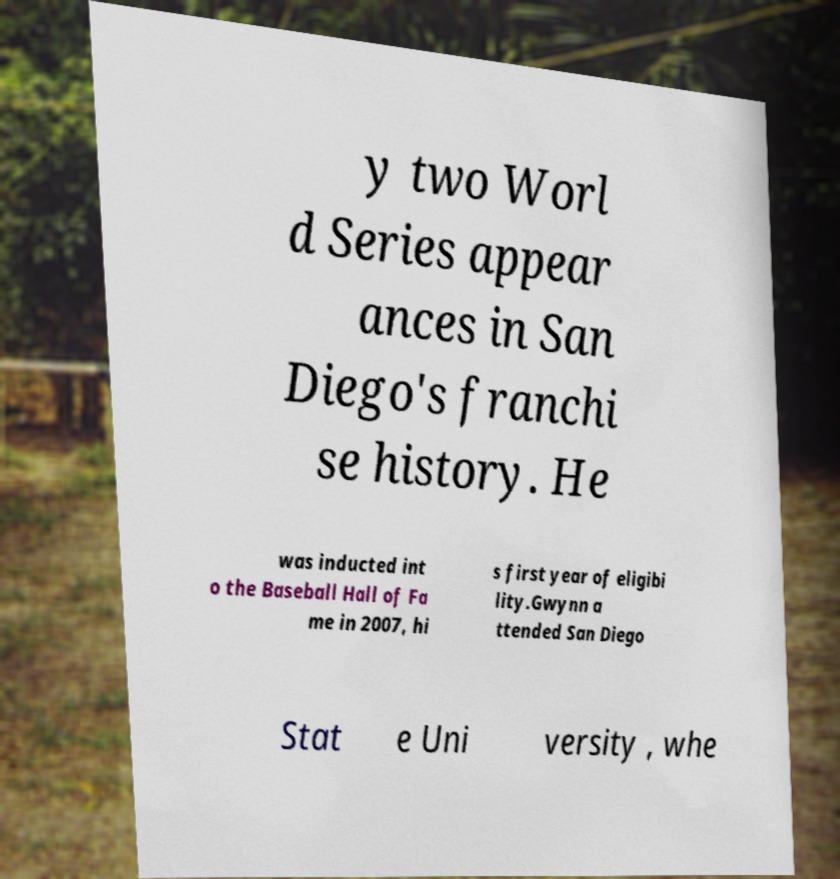Please identify and transcribe the text found in this image. y two Worl d Series appear ances in San Diego's franchi se history. He was inducted int o the Baseball Hall of Fa me in 2007, hi s first year of eligibi lity.Gwynn a ttended San Diego Stat e Uni versity , whe 